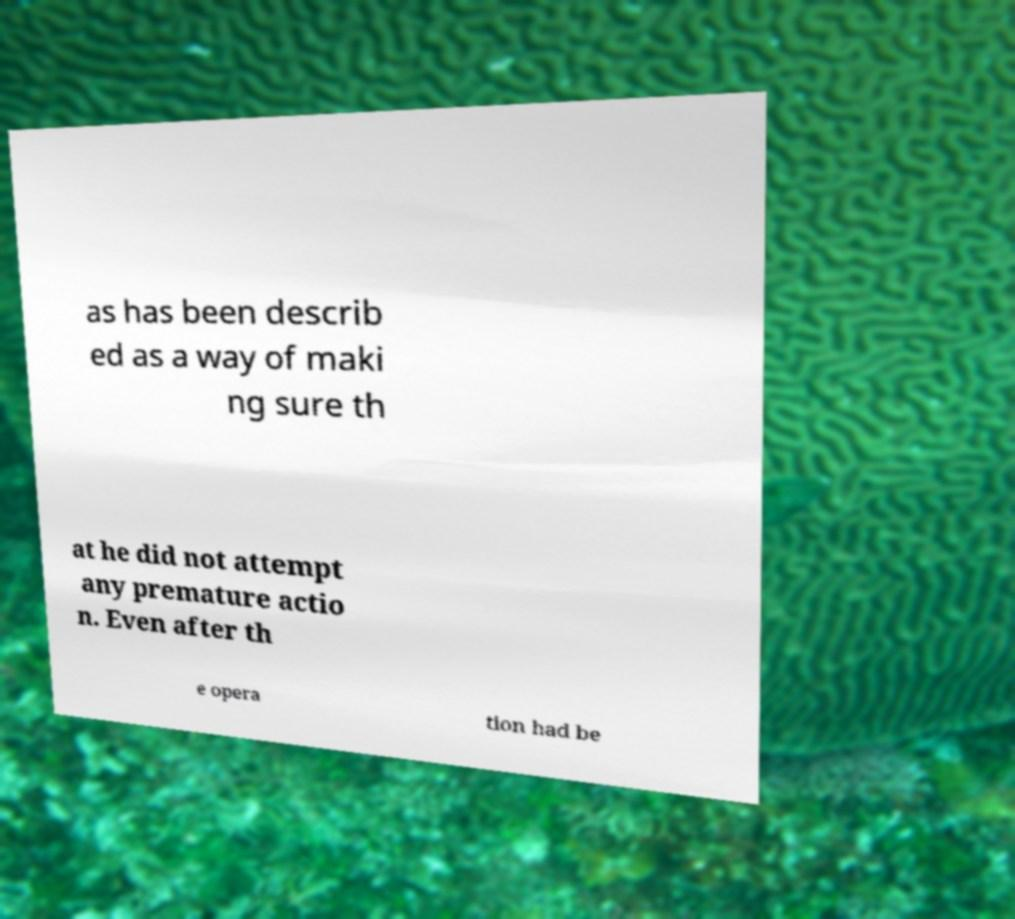Could you extract and type out the text from this image? as has been describ ed as a way of maki ng sure th at he did not attempt any premature actio n. Even after th e opera tion had be 